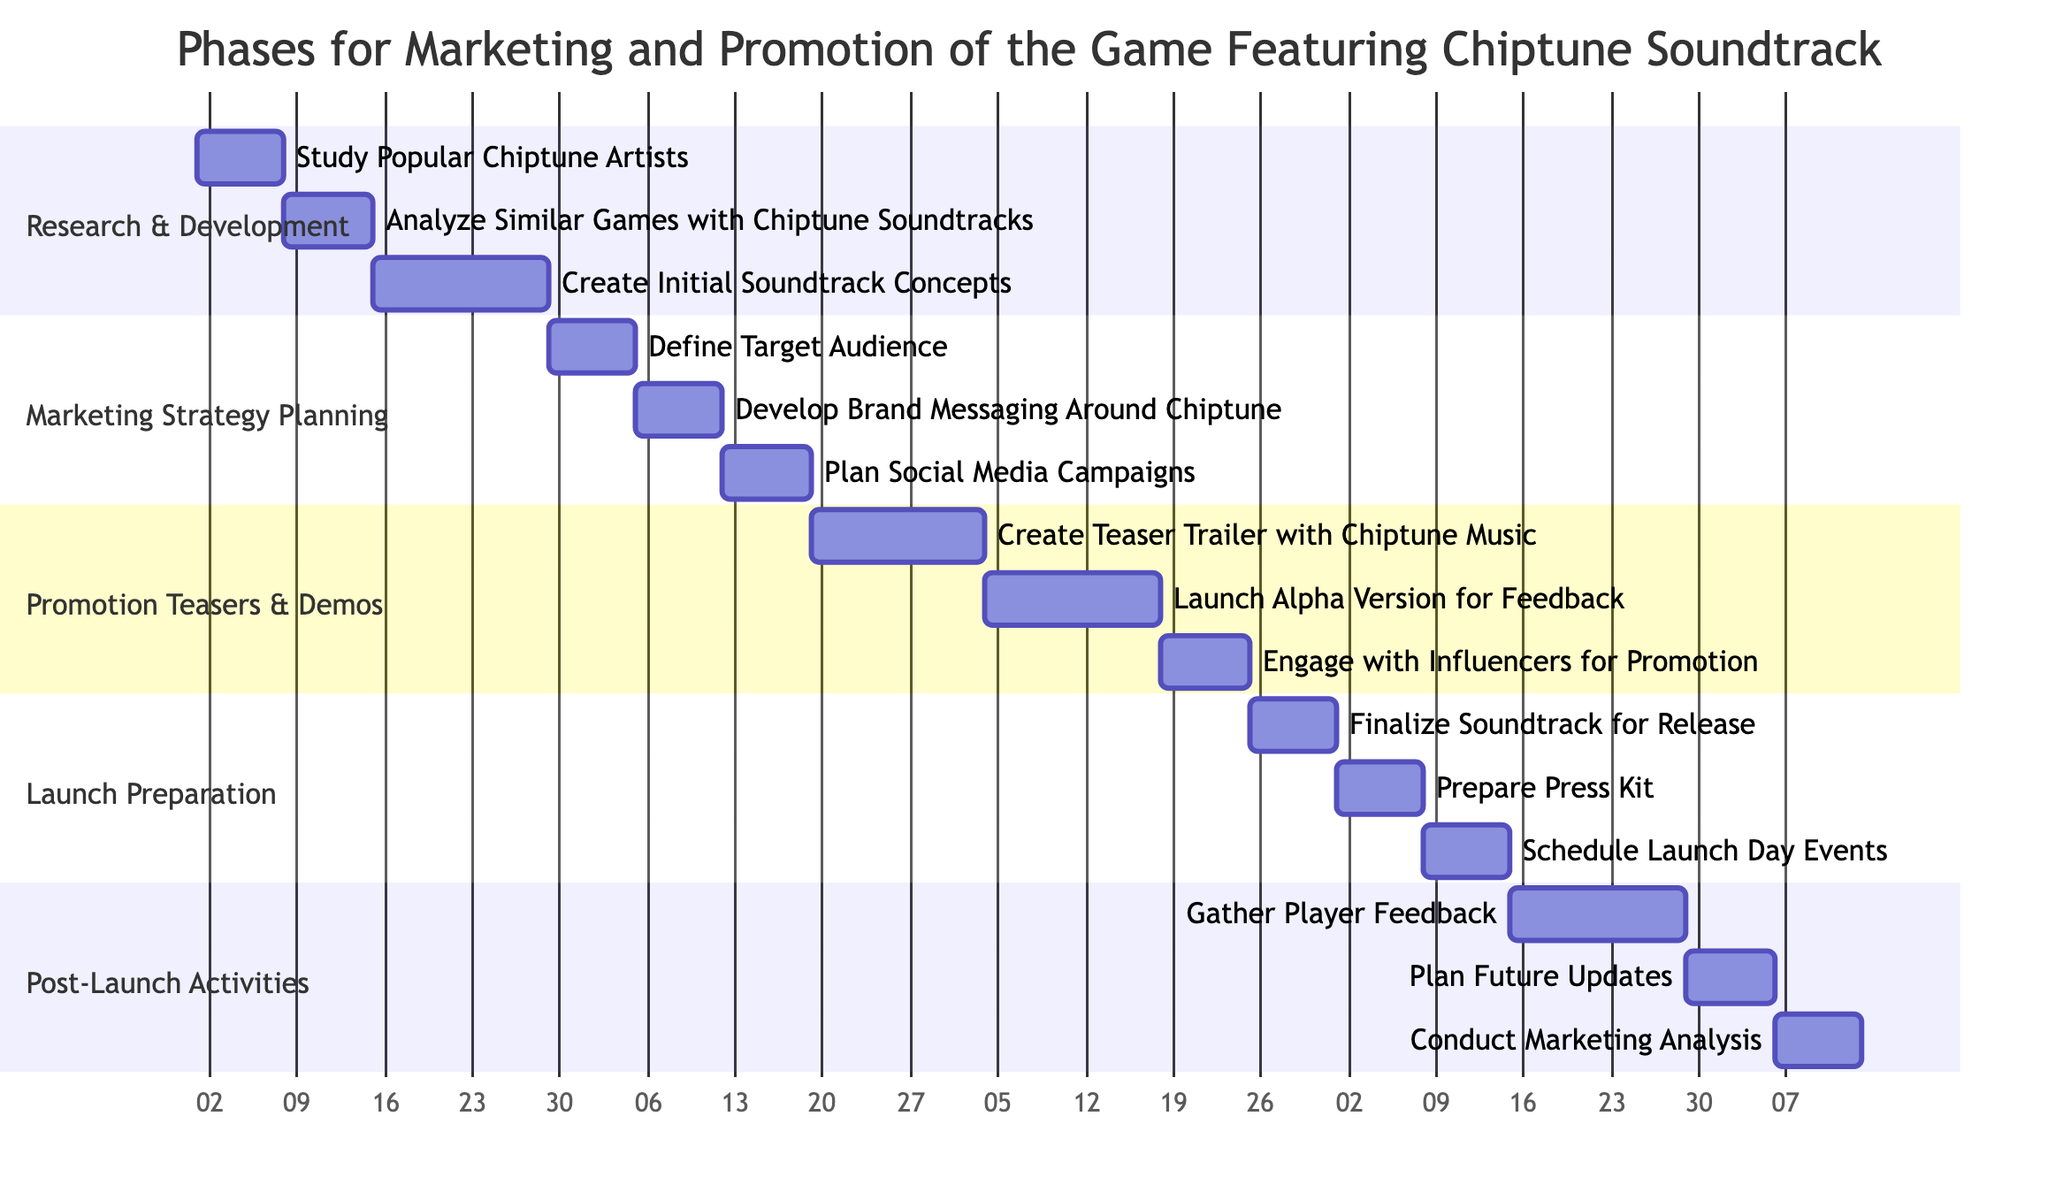What is the duration of the Research & Development phase? The diagram specifies the duration of the Research & Development phase as 4 weeks, which is indicated directly in the section header.
Answer: 4 weeks How many tasks are there in the Marketing Strategy Planning phase? By counting the individual tasks listed under the Marketing Strategy Planning section, there are three tasks: Define Target Audience, Develop Brand Messaging Around Chiptune, and Plan Social Media Campaigns.
Answer: 3 tasks What task follows the Analyze Similar Games with Chiptune Soundtracks? The diagram shows that the task that follows Analyze Similar Games with Chiptune Soundtracks is Create Initial Soundtrack Concepts, as it is positioned directly after it in the timeline.
Answer: Create Initial Soundtrack Concepts How long does the Promotion Teasers & Demos phase last? The timeline shows that the Promotion Teasers & Demos phase has a total duration of 5 weeks, as stated in the section header.
Answer: 5 weeks Which task comes just before the Finalize Soundtrack for Release? According to the diagram, the task just before Finalize Soundtrack for Release is Engage with Influencers for Promotion. This is determined by the order of tasks within the Launch Preparation phase and the tasks preceding it.
Answer: Engage with Influencers for Promotion Which section includes the task Plan Future Updates? The task Plan Future Updates is located in the Post-Launch Activities section of the Gantt chart, as indicated by the section headers in the diagram.
Answer: Post-Launch Activities How many weeks are allocated for gathering player feedback? The diagram shows that Gathering Player Feedback takes 2 weeks, as indicated by the duration specified next to that task.
Answer: 2 weeks What is the total duration of all phases combined? To find the total duration, we add the durations of all phases: 4 weeks + 3 weeks + 5 weeks + 3 weeks + 4 weeks equals 19 weeks in total.
Answer: 19 weeks 